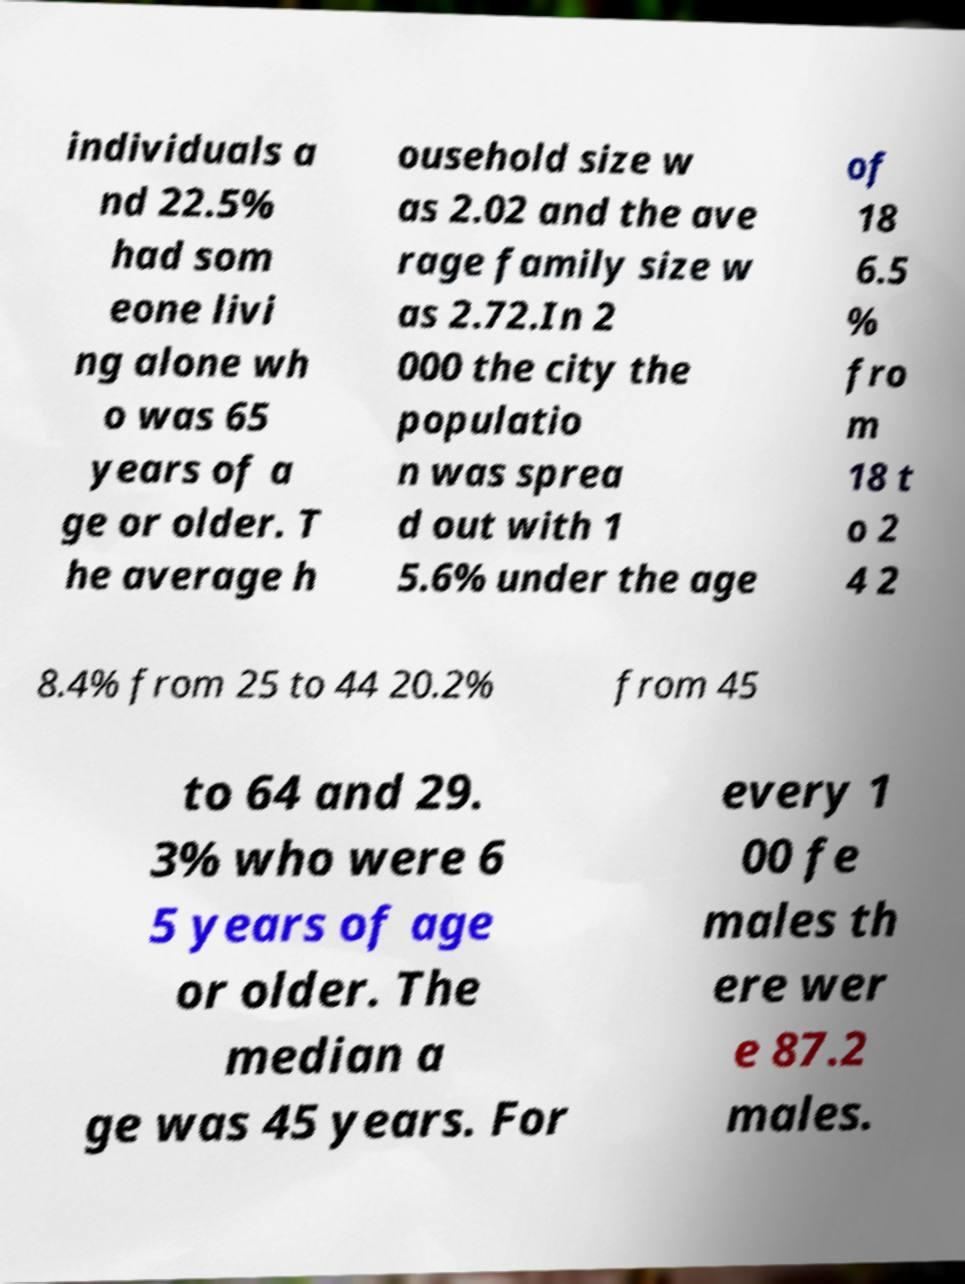For documentation purposes, I need the text within this image transcribed. Could you provide that? individuals a nd 22.5% had som eone livi ng alone wh o was 65 years of a ge or older. T he average h ousehold size w as 2.02 and the ave rage family size w as 2.72.In 2 000 the city the populatio n was sprea d out with 1 5.6% under the age of 18 6.5 % fro m 18 t o 2 4 2 8.4% from 25 to 44 20.2% from 45 to 64 and 29. 3% who were 6 5 years of age or older. The median a ge was 45 years. For every 1 00 fe males th ere wer e 87.2 males. 